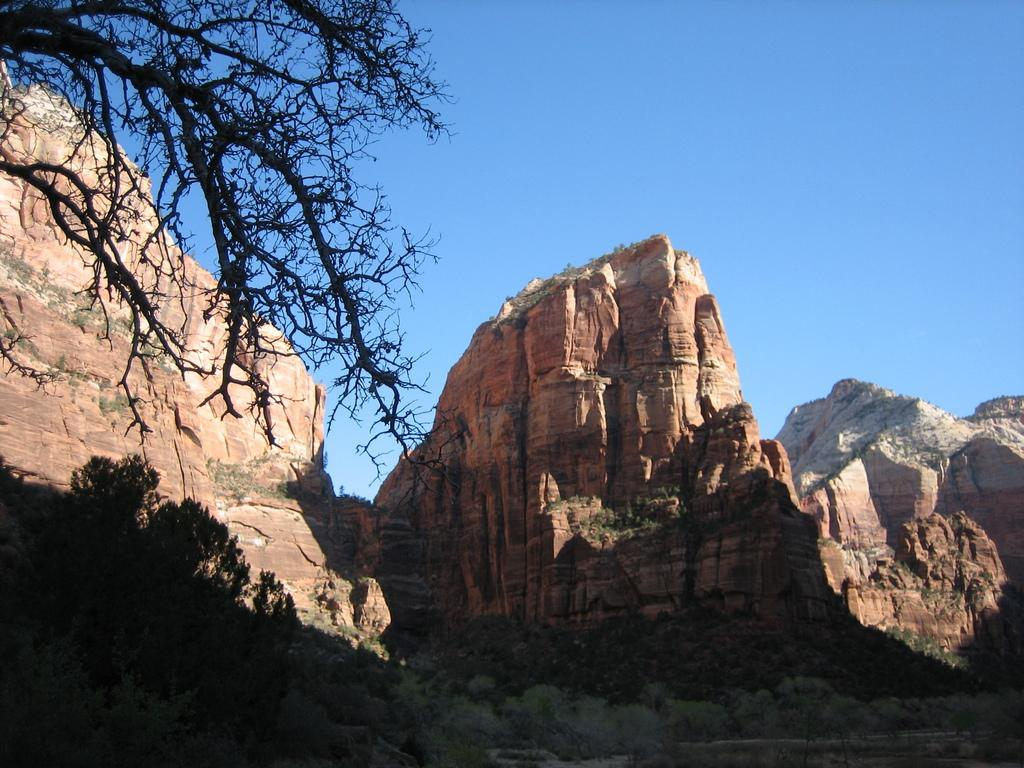What type of vegetation can be seen in the image? There are trees in the image. What geographical features are present in the image? There are hills in the image. What color is the sky in the image? The sky is blue in the image. What type of offer is being made by the coil in the image? There is no coil present in the image, so no offer can be made. 